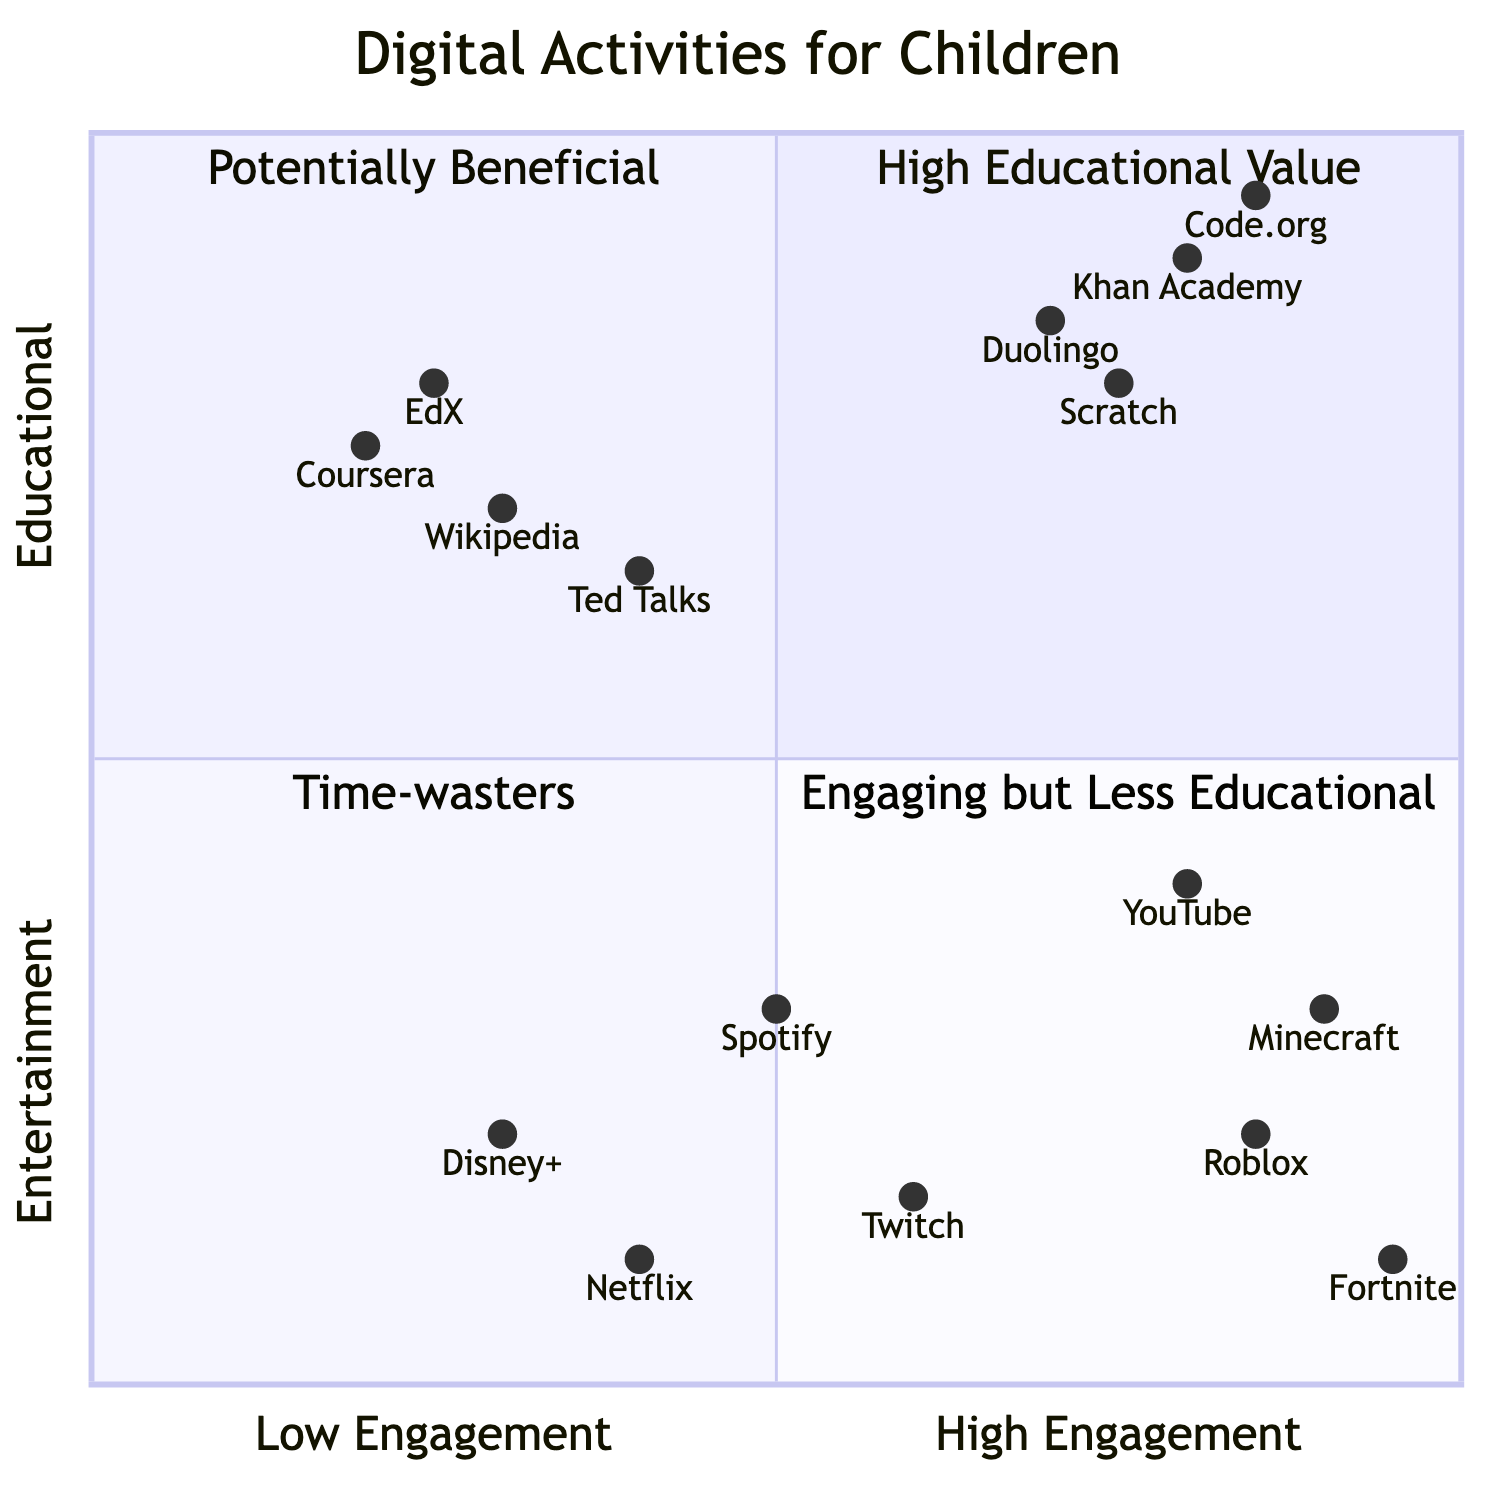What activities fall under the High Educational Value quadrant? Looking at the diagram, the High Educational Value quadrant is the top left, which includes activities that are categorized as both educational and high engagement. From the educational-high list, the activities are Khan Academy, Duolingo, Scratch, and Code.org.
Answer: Khan Academy, Duolingo, Scratch, Code.org What is the engagement level of YouTube? In the diagram, YouTube's position shows its engagement level marked at 0.8 on the x-axis, which indicates a high level of engagement, as values closer to 1 represent higher engagement levels.
Answer: 0.8 How many activities are classified as Potentially Beneficial? To find the count of activities in the Potentially Beneficial quadrant, I look at the Educational-Low and Entertainment-High lists, which include Wikipedia, Ted Talks, Coursera, EdX, Minecraft, Roblox, Fortnite, and YouTube. Counting these gives a total of 8 activities classified in this quadrant.
Answer: 8 Which activity has the highest educational value? I analyze the positions of all activities in the High Educational Value quadrant. Code.org has the highest value on the y-axis (0.95), making it the activity with the highest educational value.
Answer: Code.org Which activities are categorized as Time-wasters? For this, I check the Time-wasters quadrant, which is located at the bottom left of the diagram. The activities listed here are Netflix, Disney+, Spotify, and Twitch, as they have low educational value and low engagement.
Answer: Netflix, Disney+, Spotify, Twitch What is the educational engagement level of Minecraft? By looking at the diagram, Minecraft's position shows an engagement level of 0.3 on the y-axis. This indicates that it has low educational value.
Answer: 0.3 How can you determine the differences between Educational-High and Educational-Low activities? Educational-High includes activities that have high engagement and educational value (Khan Academy, Duolingo, Scratch, Code.org), while Educational-Low consists of activities that, despite being educational, have lower engagement value (Wikipedia, Ted Talks, Coursera, EdX). The key difference lies in their respective y-axis values, where Educational-High has values significantly above those in Educational-Low.
Answer: High engagement vs. low engagement What is the lowest engagement activity among the entertainment options? The lowest engagement level among the entertainment options is Twitch with an engagement level of 0.15, as indicated by its position in the Entertainment-Low quadrant.
Answer: Twitch 